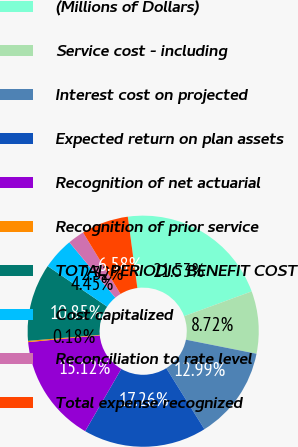Convert chart. <chart><loc_0><loc_0><loc_500><loc_500><pie_chart><fcel>(Millions of Dollars)<fcel>Service cost - including<fcel>Interest cost on projected<fcel>Expected return on plan assets<fcel>Recognition of net actuarial<fcel>Recognition of prior service<fcel>TOTAL PERIODIC BENEFIT COST<fcel>Cost capitalized<fcel>Reconciliation to rate level<fcel>Total expense recognized<nl><fcel>21.53%<fcel>8.72%<fcel>12.99%<fcel>17.26%<fcel>15.12%<fcel>0.18%<fcel>10.85%<fcel>4.45%<fcel>2.32%<fcel>6.58%<nl></chart> 